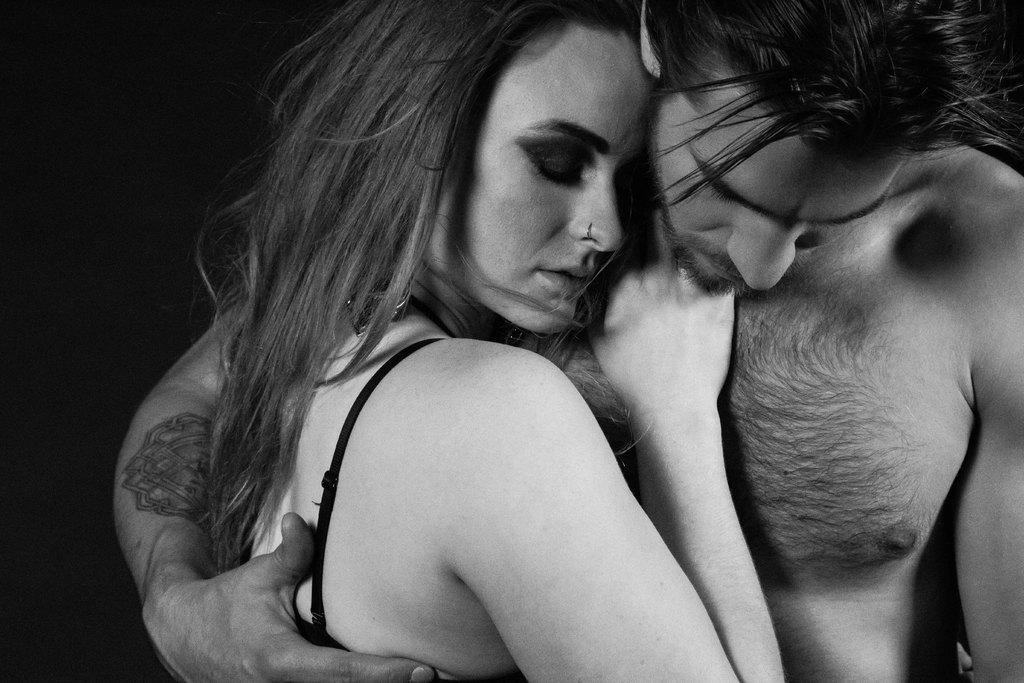Who are the people in the image? There is a man and a woman in the image. What are the man and woman doing in the image? The man and woman are hugging each other. What color is the background of the image? The background of the image is black. How many trees can be seen in the image? There are no trees visible in the image. What type of flight is the man and woman taking in the image? There is no flight depicted in the image; the man and woman are hugging each other. 